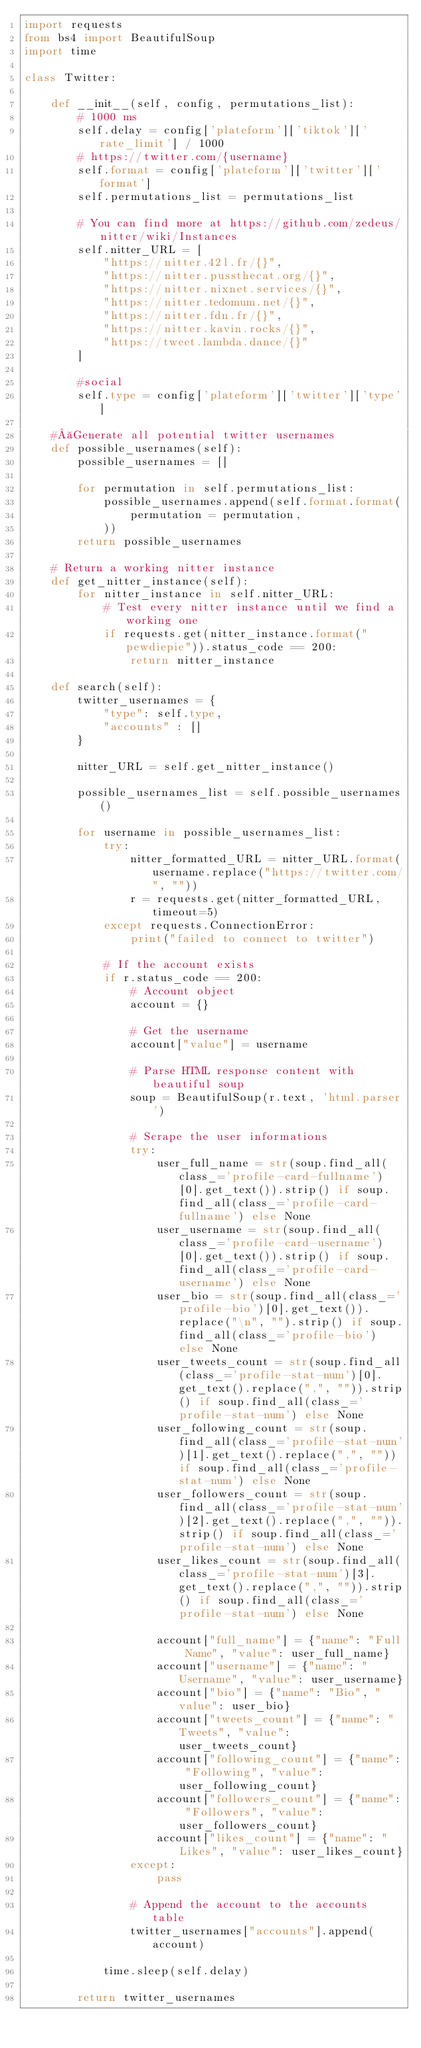Convert code to text. <code><loc_0><loc_0><loc_500><loc_500><_Python_>import requests
from bs4 import BeautifulSoup
import time

class Twitter:

    def __init__(self, config, permutations_list):
        # 1000 ms
        self.delay = config['plateform']['tiktok']['rate_limit'] / 1000
        # https://twitter.com/{username}
        self.format = config['plateform']['twitter']['format']
        self.permutations_list = permutations_list

        # You can find more at https://github.com/zedeus/nitter/wiki/Instances
        self.nitter_URL = [
            "https://nitter.42l.fr/{}",
            "https://nitter.pussthecat.org/{}",
            "https://nitter.nixnet.services/{}",
            "https://nitter.tedomum.net/{}",
            "https://nitter.fdn.fr/{}",
            "https://nitter.kavin.rocks/{}",
            "https://tweet.lambda.dance/{}"
        ]

        #social
        self.type = config['plateform']['twitter']['type']

    # Generate all potential twitter usernames
    def possible_usernames(self):
        possible_usernames = []

        for permutation in self.permutations_list:
            possible_usernames.append(self.format.format(
                permutation = permutation,
            ))
        return possible_usernames

    # Return a working nitter instance
    def get_nitter_instance(self):
        for nitter_instance in self.nitter_URL:
            # Test every nitter instance until we find a working one
            if requests.get(nitter_instance.format("pewdiepie")).status_code == 200:
                return nitter_instance

    def search(self):
        twitter_usernames = {
            "type": self.type,
            "accounts" : []
        }

        nitter_URL = self.get_nitter_instance()

        possible_usernames_list = self.possible_usernames()

        for username in possible_usernames_list:
            try:
                nitter_formatted_URL = nitter_URL.format(username.replace("https://twitter.com/", ""))
                r = requests.get(nitter_formatted_URL, timeout=5)
            except requests.ConnectionError:
                print("failed to connect to twitter")
            
            # If the account exists
            if r.status_code == 200:
                # Account object
                account = {}

                # Get the username
                account["value"] = username
                
                # Parse HTML response content with beautiful soup 
                soup = BeautifulSoup(r.text, 'html.parser')
                
                # Scrape the user informations
                try:
                    user_full_name = str(soup.find_all(class_='profile-card-fullname')[0].get_text()).strip() if soup.find_all(class_='profile-card-fullname') else None
                    user_username = str(soup.find_all(class_='profile-card-username')[0].get_text()).strip() if soup.find_all(class_='profile-card-username') else None
                    user_bio = str(soup.find_all(class_='profile-bio')[0].get_text()).replace("\n", "").strip() if soup.find_all(class_='profile-bio') else None
                    user_tweets_count = str(soup.find_all(class_='profile-stat-num')[0].get_text().replace(",", "")).strip() if soup.find_all(class_='profile-stat-num') else None
                    user_following_count = str(soup.find_all(class_='profile-stat-num')[1].get_text().replace(",", "")) if soup.find_all(class_='profile-stat-num') else None
                    user_followers_count = str(soup.find_all(class_='profile-stat-num')[2].get_text().replace(",", "")).strip() if soup.find_all(class_='profile-stat-num') else None
                    user_likes_count = str(soup.find_all(class_='profile-stat-num')[3].get_text().replace(",", "")).strip() if soup.find_all(class_='profile-stat-num') else None

                    account["full_name"] = {"name": "Full Name", "value": user_full_name}
                    account["username"] = {"name": "Username", "value": user_username}
                    account["bio"] = {"name": "Bio", "value": user_bio}
                    account["tweets_count"] = {"name": "Tweets", "value": user_tweets_count}
                    account["following_count"] = {"name": "Following", "value": user_following_count}
                    account["followers_count"] = {"name": "Followers", "value": user_followers_count}
                    account["likes_count"] = {"name": "Likes", "value": user_likes_count}
                except:
                    pass
                
                # Append the account to the accounts table
                twitter_usernames["accounts"].append(account)

            time.sleep(self.delay)

        return twitter_usernames</code> 